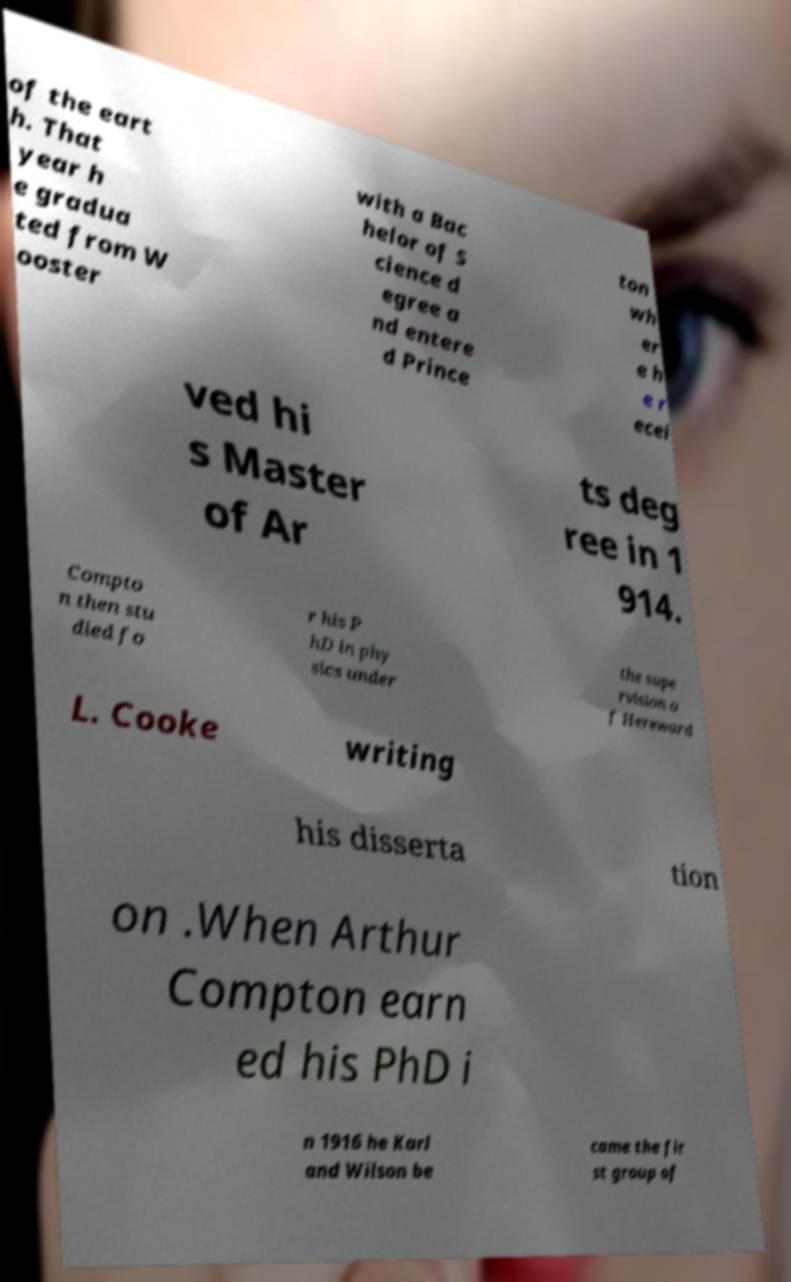Could you assist in decoding the text presented in this image and type it out clearly? of the eart h. That year h e gradua ted from W ooster with a Bac helor of S cience d egree a nd entere d Prince ton wh er e h e r ecei ved hi s Master of Ar ts deg ree in 1 914. Compto n then stu died fo r his P hD in phy sics under the supe rvision o f Hereward L. Cooke writing his disserta tion on .When Arthur Compton earn ed his PhD i n 1916 he Karl and Wilson be came the fir st group of 